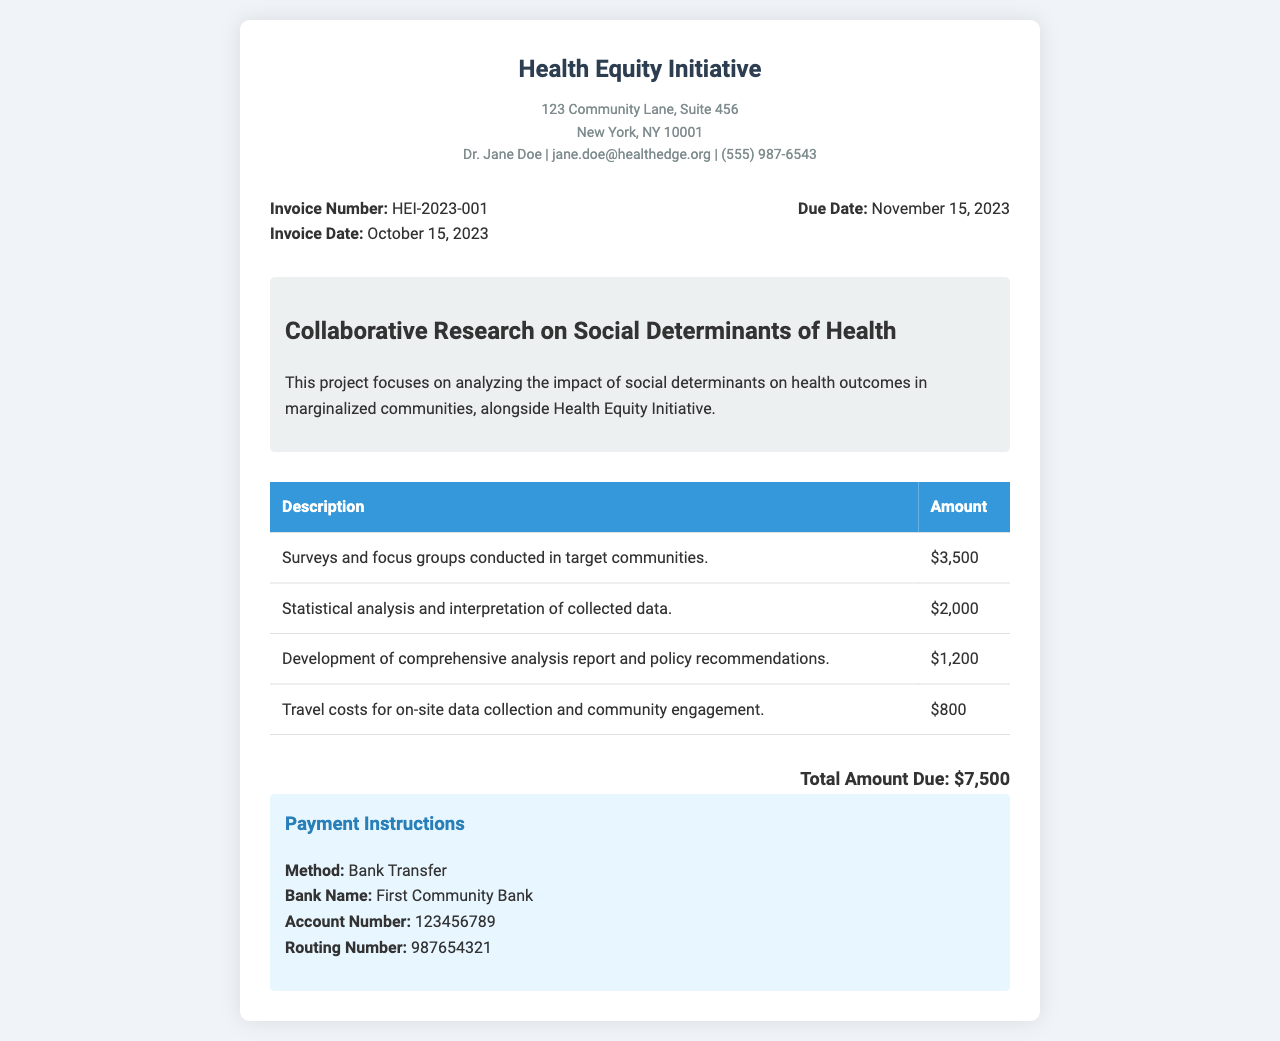What is the invoice number? The invoice number is specifically mentioned in the document as a unique identifier for this invoice.
Answer: HEI-2023-001 What is the total amount due? The total amount due is calculated from the sum of all expenses listed in the document.
Answer: $7,500 What is the due date for payment? The due date is the final date by which payment should be made, stated clearly in the document.
Answer: November 15, 2023 Who is the contact person for the Health Equity Initiative? The contact person is identified in the header of the document, allowing individuals to reach out if needed.
Answer: Dr. Jane Doe What type of project is this invoice for? The type of project is outlined in the project description, highlighting the focus of the research.
Answer: Collaborative Research on Social Determinants of Health What method of payment is specified? The method of payment is clearly stated in the payment instructions section of the document.
Answer: Bank Transfer What is included in the statistical analysis expense? This expense pertains to a specific activity related to data processing which is outlined.
Answer: Statistical analysis and interpretation of collected data What expense relates to community engagement? This question targets the specific cost associated with engaging the community, listed in the document.
Answer: Travel costs for on-site data collection and community engagement How much was spent on developing the analysis report? The amount for this specific task is listed alongside it in the document, providing clarity on expenses.
Answer: $1,200 